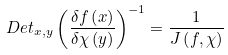<formula> <loc_0><loc_0><loc_500><loc_500>D e t _ { x , y } \left ( \frac { \delta f \left ( x \right ) } { \delta \chi \left ( y \right ) } \right ) ^ { - 1 } = \frac { 1 } { J \left ( f , \chi \right ) }</formula> 